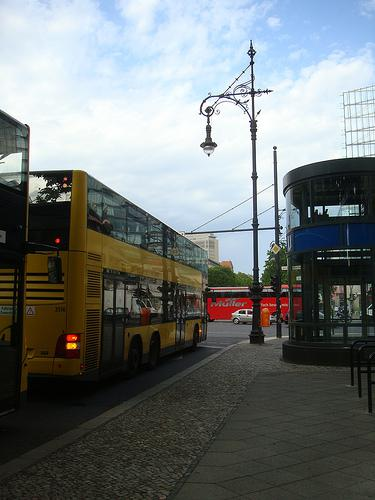Question: when will the streetlamp be on?
Choices:
A. At night.
B. When it gets dark.
C. At dusk.
D. At dawn.
Answer with the letter. Answer: B Question: why are the brake lights on?
Choices:
A. They are being repaired.
B. The bus is currently stopped.
C. The car is slowing down.
D. The man slammed on the breaks.
Answer with the letter. Answer: B Question: who is standing on the sidewalk, behind the yellow bus, to the right?
Choices:
A. The children.
B. The bus driver.
C. The crossing guard.
D. The photographer.
Answer with the letter. Answer: D Question: what color is the facade of the round glass building on the right?
Choices:
A. Black and blue.
B. Purple and gold.
C. Green and yellow.
D. Black and orange.
Answer with the letter. Answer: A 